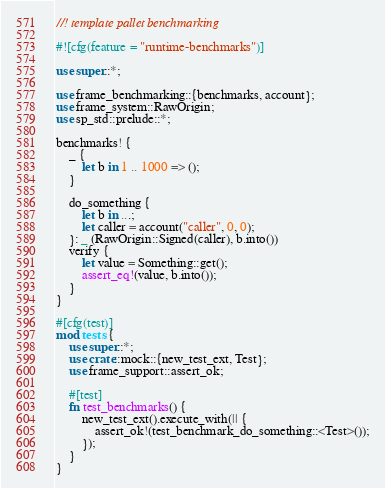Convert code to text. <code><loc_0><loc_0><loc_500><loc_500><_Rust_>//! template pallet benchmarking

#![cfg(feature = "runtime-benchmarks")]

use super::*;

use frame_benchmarking::{benchmarks, account};
use frame_system::RawOrigin;
use sp_std::prelude::*;

benchmarks! {
    _ {
        let b in 1 .. 1000 => ();
    }

    do_something {
        let b in ...;
        let caller = account("caller", 0, 0);
    }: _ (RawOrigin::Signed(caller), b.into())
    verify {
        let value = Something::get();
        assert_eq!(value, b.into());
    }
}

#[cfg(test)]
mod tests {
    use super::*;
    use crate::mock::{new_test_ext, Test};
    use frame_support::assert_ok;

    #[test]
    fn test_benchmarks() {
        new_test_ext().execute_with(|| {
            assert_ok!(test_benchmark_do_something::<Test>());
        });
    }
}

</code> 